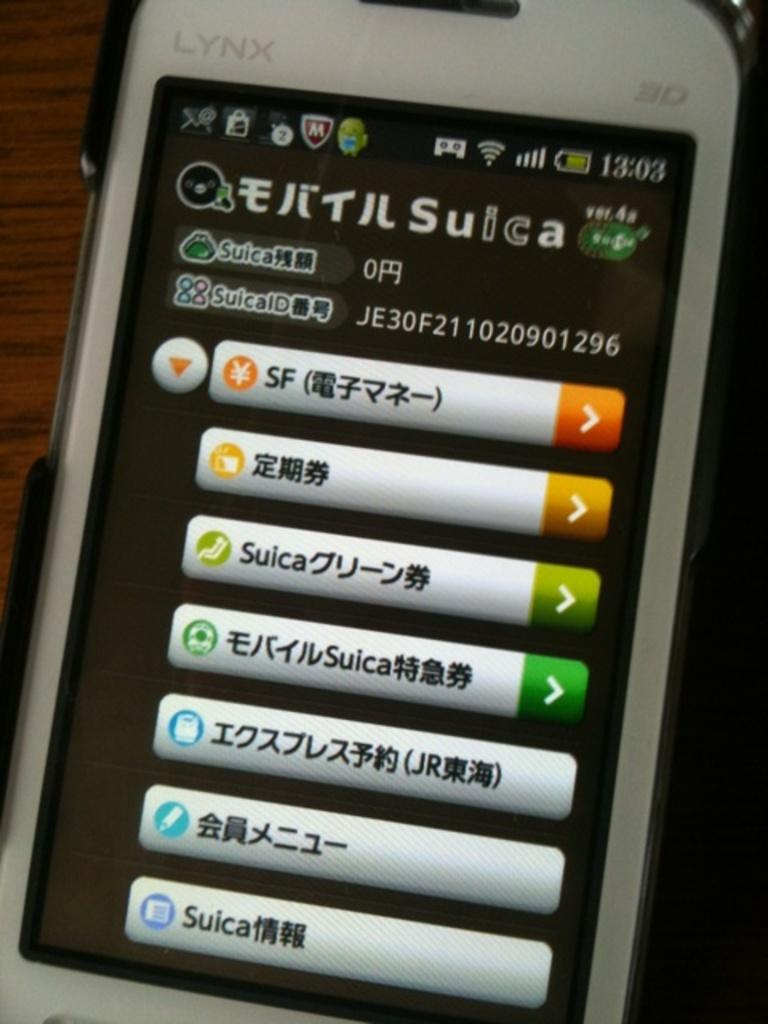<image>
Present a compact description of the photo's key features. Options of choices on a phone in a language that is not English. 